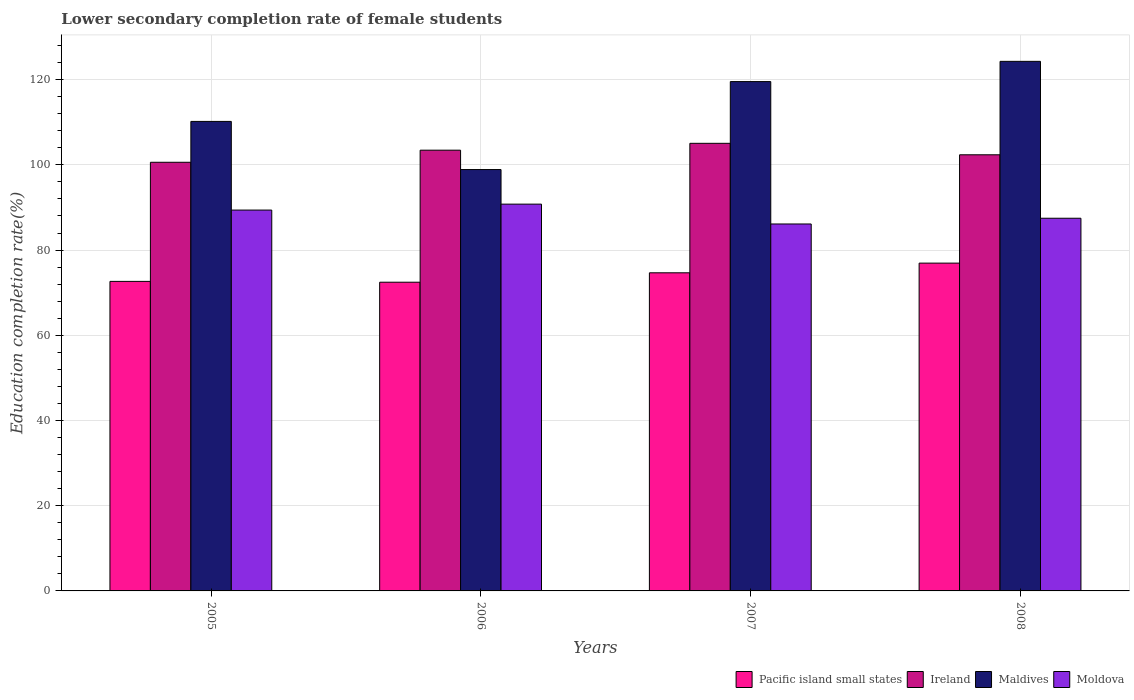How many different coloured bars are there?
Your response must be concise. 4. How many groups of bars are there?
Make the answer very short. 4. Are the number of bars on each tick of the X-axis equal?
Give a very brief answer. Yes. What is the lower secondary completion rate of female students in Moldova in 2006?
Your answer should be compact. 90.78. Across all years, what is the maximum lower secondary completion rate of female students in Ireland?
Your response must be concise. 105.05. Across all years, what is the minimum lower secondary completion rate of female students in Maldives?
Your answer should be compact. 98.89. In which year was the lower secondary completion rate of female students in Maldives maximum?
Your answer should be compact. 2008. In which year was the lower secondary completion rate of female students in Moldova minimum?
Offer a terse response. 2007. What is the total lower secondary completion rate of female students in Moldova in the graph?
Ensure brevity in your answer.  353.75. What is the difference between the lower secondary completion rate of female students in Ireland in 2005 and that in 2007?
Provide a succinct answer. -4.45. What is the difference between the lower secondary completion rate of female students in Ireland in 2007 and the lower secondary completion rate of female students in Moldova in 2005?
Provide a short and direct response. 15.67. What is the average lower secondary completion rate of female students in Maldives per year?
Your answer should be very brief. 113.23. In the year 2008, what is the difference between the lower secondary completion rate of female students in Moldova and lower secondary completion rate of female students in Pacific island small states?
Offer a very short reply. 10.53. What is the ratio of the lower secondary completion rate of female students in Pacific island small states in 2005 to that in 2008?
Provide a short and direct response. 0.94. Is the difference between the lower secondary completion rate of female students in Moldova in 2005 and 2008 greater than the difference between the lower secondary completion rate of female students in Pacific island small states in 2005 and 2008?
Provide a short and direct response. Yes. What is the difference between the highest and the second highest lower secondary completion rate of female students in Pacific island small states?
Ensure brevity in your answer.  2.27. What is the difference between the highest and the lowest lower secondary completion rate of female students in Ireland?
Make the answer very short. 4.45. In how many years, is the lower secondary completion rate of female students in Moldova greater than the average lower secondary completion rate of female students in Moldova taken over all years?
Provide a short and direct response. 2. What does the 4th bar from the left in 2006 represents?
Provide a short and direct response. Moldova. What does the 4th bar from the right in 2006 represents?
Provide a succinct answer. Pacific island small states. Is it the case that in every year, the sum of the lower secondary completion rate of female students in Maldives and lower secondary completion rate of female students in Pacific island small states is greater than the lower secondary completion rate of female students in Ireland?
Your answer should be compact. Yes. How many bars are there?
Your response must be concise. 16. Are all the bars in the graph horizontal?
Give a very brief answer. No. Where does the legend appear in the graph?
Offer a terse response. Bottom right. How many legend labels are there?
Keep it short and to the point. 4. What is the title of the graph?
Your answer should be very brief. Lower secondary completion rate of female students. Does "Spain" appear as one of the legend labels in the graph?
Provide a short and direct response. No. What is the label or title of the Y-axis?
Your answer should be very brief. Education completion rate(%). What is the Education completion rate(%) in Pacific island small states in 2005?
Your response must be concise. 72.65. What is the Education completion rate(%) of Ireland in 2005?
Keep it short and to the point. 100.6. What is the Education completion rate(%) of Maldives in 2005?
Your answer should be very brief. 110.19. What is the Education completion rate(%) in Moldova in 2005?
Your answer should be compact. 89.38. What is the Education completion rate(%) of Pacific island small states in 2006?
Offer a very short reply. 72.45. What is the Education completion rate(%) in Ireland in 2006?
Provide a short and direct response. 103.44. What is the Education completion rate(%) in Maldives in 2006?
Your answer should be very brief. 98.89. What is the Education completion rate(%) in Moldova in 2006?
Make the answer very short. 90.78. What is the Education completion rate(%) of Pacific island small states in 2007?
Your response must be concise. 74.66. What is the Education completion rate(%) of Ireland in 2007?
Offer a very short reply. 105.05. What is the Education completion rate(%) in Maldives in 2007?
Offer a very short reply. 119.54. What is the Education completion rate(%) in Moldova in 2007?
Give a very brief answer. 86.12. What is the Education completion rate(%) in Pacific island small states in 2008?
Make the answer very short. 76.94. What is the Education completion rate(%) of Ireland in 2008?
Offer a terse response. 102.36. What is the Education completion rate(%) of Maldives in 2008?
Your answer should be compact. 124.29. What is the Education completion rate(%) of Moldova in 2008?
Your response must be concise. 87.47. Across all years, what is the maximum Education completion rate(%) of Pacific island small states?
Provide a short and direct response. 76.94. Across all years, what is the maximum Education completion rate(%) in Ireland?
Ensure brevity in your answer.  105.05. Across all years, what is the maximum Education completion rate(%) of Maldives?
Your response must be concise. 124.29. Across all years, what is the maximum Education completion rate(%) of Moldova?
Offer a terse response. 90.78. Across all years, what is the minimum Education completion rate(%) of Pacific island small states?
Make the answer very short. 72.45. Across all years, what is the minimum Education completion rate(%) of Ireland?
Your response must be concise. 100.6. Across all years, what is the minimum Education completion rate(%) of Maldives?
Keep it short and to the point. 98.89. Across all years, what is the minimum Education completion rate(%) in Moldova?
Keep it short and to the point. 86.12. What is the total Education completion rate(%) of Pacific island small states in the graph?
Ensure brevity in your answer.  296.7. What is the total Education completion rate(%) in Ireland in the graph?
Your answer should be compact. 411.46. What is the total Education completion rate(%) in Maldives in the graph?
Ensure brevity in your answer.  452.91. What is the total Education completion rate(%) of Moldova in the graph?
Provide a short and direct response. 353.75. What is the difference between the Education completion rate(%) in Pacific island small states in 2005 and that in 2006?
Provide a short and direct response. 0.19. What is the difference between the Education completion rate(%) of Ireland in 2005 and that in 2006?
Your answer should be very brief. -2.84. What is the difference between the Education completion rate(%) of Maldives in 2005 and that in 2006?
Provide a short and direct response. 11.3. What is the difference between the Education completion rate(%) of Moldova in 2005 and that in 2006?
Make the answer very short. -1.4. What is the difference between the Education completion rate(%) in Pacific island small states in 2005 and that in 2007?
Ensure brevity in your answer.  -2.02. What is the difference between the Education completion rate(%) of Ireland in 2005 and that in 2007?
Your response must be concise. -4.45. What is the difference between the Education completion rate(%) of Maldives in 2005 and that in 2007?
Make the answer very short. -9.35. What is the difference between the Education completion rate(%) in Moldova in 2005 and that in 2007?
Your answer should be very brief. 3.26. What is the difference between the Education completion rate(%) of Pacific island small states in 2005 and that in 2008?
Provide a short and direct response. -4.29. What is the difference between the Education completion rate(%) of Ireland in 2005 and that in 2008?
Make the answer very short. -1.76. What is the difference between the Education completion rate(%) in Maldives in 2005 and that in 2008?
Your answer should be compact. -14.1. What is the difference between the Education completion rate(%) of Moldova in 2005 and that in 2008?
Give a very brief answer. 1.92. What is the difference between the Education completion rate(%) of Pacific island small states in 2006 and that in 2007?
Provide a succinct answer. -2.21. What is the difference between the Education completion rate(%) in Ireland in 2006 and that in 2007?
Make the answer very short. -1.61. What is the difference between the Education completion rate(%) of Maldives in 2006 and that in 2007?
Your answer should be compact. -20.65. What is the difference between the Education completion rate(%) of Moldova in 2006 and that in 2007?
Offer a very short reply. 4.66. What is the difference between the Education completion rate(%) of Pacific island small states in 2006 and that in 2008?
Your answer should be compact. -4.48. What is the difference between the Education completion rate(%) of Ireland in 2006 and that in 2008?
Your answer should be very brief. 1.08. What is the difference between the Education completion rate(%) of Maldives in 2006 and that in 2008?
Ensure brevity in your answer.  -25.4. What is the difference between the Education completion rate(%) of Moldova in 2006 and that in 2008?
Provide a short and direct response. 3.31. What is the difference between the Education completion rate(%) of Pacific island small states in 2007 and that in 2008?
Provide a succinct answer. -2.27. What is the difference between the Education completion rate(%) in Ireland in 2007 and that in 2008?
Ensure brevity in your answer.  2.69. What is the difference between the Education completion rate(%) in Maldives in 2007 and that in 2008?
Offer a very short reply. -4.75. What is the difference between the Education completion rate(%) in Moldova in 2007 and that in 2008?
Ensure brevity in your answer.  -1.34. What is the difference between the Education completion rate(%) of Pacific island small states in 2005 and the Education completion rate(%) of Ireland in 2006?
Provide a succinct answer. -30.79. What is the difference between the Education completion rate(%) of Pacific island small states in 2005 and the Education completion rate(%) of Maldives in 2006?
Your answer should be compact. -26.25. What is the difference between the Education completion rate(%) in Pacific island small states in 2005 and the Education completion rate(%) in Moldova in 2006?
Provide a succinct answer. -18.13. What is the difference between the Education completion rate(%) in Ireland in 2005 and the Education completion rate(%) in Maldives in 2006?
Ensure brevity in your answer.  1.71. What is the difference between the Education completion rate(%) of Ireland in 2005 and the Education completion rate(%) of Moldova in 2006?
Offer a terse response. 9.82. What is the difference between the Education completion rate(%) of Maldives in 2005 and the Education completion rate(%) of Moldova in 2006?
Make the answer very short. 19.41. What is the difference between the Education completion rate(%) of Pacific island small states in 2005 and the Education completion rate(%) of Ireland in 2007?
Give a very brief answer. -32.4. What is the difference between the Education completion rate(%) of Pacific island small states in 2005 and the Education completion rate(%) of Maldives in 2007?
Ensure brevity in your answer.  -46.89. What is the difference between the Education completion rate(%) of Pacific island small states in 2005 and the Education completion rate(%) of Moldova in 2007?
Provide a succinct answer. -13.47. What is the difference between the Education completion rate(%) in Ireland in 2005 and the Education completion rate(%) in Maldives in 2007?
Your answer should be very brief. -18.93. What is the difference between the Education completion rate(%) in Ireland in 2005 and the Education completion rate(%) in Moldova in 2007?
Your response must be concise. 14.48. What is the difference between the Education completion rate(%) in Maldives in 2005 and the Education completion rate(%) in Moldova in 2007?
Provide a succinct answer. 24.07. What is the difference between the Education completion rate(%) in Pacific island small states in 2005 and the Education completion rate(%) in Ireland in 2008?
Give a very brief answer. -29.71. What is the difference between the Education completion rate(%) of Pacific island small states in 2005 and the Education completion rate(%) of Maldives in 2008?
Offer a very short reply. -51.64. What is the difference between the Education completion rate(%) in Pacific island small states in 2005 and the Education completion rate(%) in Moldova in 2008?
Make the answer very short. -14.82. What is the difference between the Education completion rate(%) in Ireland in 2005 and the Education completion rate(%) in Maldives in 2008?
Make the answer very short. -23.69. What is the difference between the Education completion rate(%) of Ireland in 2005 and the Education completion rate(%) of Moldova in 2008?
Offer a terse response. 13.14. What is the difference between the Education completion rate(%) of Maldives in 2005 and the Education completion rate(%) of Moldova in 2008?
Your answer should be compact. 22.73. What is the difference between the Education completion rate(%) in Pacific island small states in 2006 and the Education completion rate(%) in Ireland in 2007?
Your response must be concise. -32.6. What is the difference between the Education completion rate(%) in Pacific island small states in 2006 and the Education completion rate(%) in Maldives in 2007?
Your response must be concise. -47.09. What is the difference between the Education completion rate(%) in Pacific island small states in 2006 and the Education completion rate(%) in Moldova in 2007?
Give a very brief answer. -13.67. What is the difference between the Education completion rate(%) of Ireland in 2006 and the Education completion rate(%) of Maldives in 2007?
Keep it short and to the point. -16.1. What is the difference between the Education completion rate(%) of Ireland in 2006 and the Education completion rate(%) of Moldova in 2007?
Ensure brevity in your answer.  17.32. What is the difference between the Education completion rate(%) in Maldives in 2006 and the Education completion rate(%) in Moldova in 2007?
Your answer should be compact. 12.77. What is the difference between the Education completion rate(%) in Pacific island small states in 2006 and the Education completion rate(%) in Ireland in 2008?
Keep it short and to the point. -29.91. What is the difference between the Education completion rate(%) in Pacific island small states in 2006 and the Education completion rate(%) in Maldives in 2008?
Give a very brief answer. -51.84. What is the difference between the Education completion rate(%) of Pacific island small states in 2006 and the Education completion rate(%) of Moldova in 2008?
Give a very brief answer. -15.01. What is the difference between the Education completion rate(%) of Ireland in 2006 and the Education completion rate(%) of Maldives in 2008?
Your answer should be very brief. -20.85. What is the difference between the Education completion rate(%) in Ireland in 2006 and the Education completion rate(%) in Moldova in 2008?
Keep it short and to the point. 15.98. What is the difference between the Education completion rate(%) of Maldives in 2006 and the Education completion rate(%) of Moldova in 2008?
Keep it short and to the point. 11.43. What is the difference between the Education completion rate(%) in Pacific island small states in 2007 and the Education completion rate(%) in Ireland in 2008?
Offer a terse response. -27.7. What is the difference between the Education completion rate(%) in Pacific island small states in 2007 and the Education completion rate(%) in Maldives in 2008?
Make the answer very short. -49.63. What is the difference between the Education completion rate(%) in Pacific island small states in 2007 and the Education completion rate(%) in Moldova in 2008?
Give a very brief answer. -12.8. What is the difference between the Education completion rate(%) of Ireland in 2007 and the Education completion rate(%) of Maldives in 2008?
Offer a terse response. -19.24. What is the difference between the Education completion rate(%) of Ireland in 2007 and the Education completion rate(%) of Moldova in 2008?
Keep it short and to the point. 17.59. What is the difference between the Education completion rate(%) in Maldives in 2007 and the Education completion rate(%) in Moldova in 2008?
Your answer should be compact. 32.07. What is the average Education completion rate(%) in Pacific island small states per year?
Your response must be concise. 74.17. What is the average Education completion rate(%) of Ireland per year?
Provide a short and direct response. 102.86. What is the average Education completion rate(%) in Maldives per year?
Provide a succinct answer. 113.23. What is the average Education completion rate(%) in Moldova per year?
Your answer should be very brief. 88.44. In the year 2005, what is the difference between the Education completion rate(%) of Pacific island small states and Education completion rate(%) of Ireland?
Ensure brevity in your answer.  -27.96. In the year 2005, what is the difference between the Education completion rate(%) in Pacific island small states and Education completion rate(%) in Maldives?
Provide a short and direct response. -37.55. In the year 2005, what is the difference between the Education completion rate(%) of Pacific island small states and Education completion rate(%) of Moldova?
Your response must be concise. -16.74. In the year 2005, what is the difference between the Education completion rate(%) in Ireland and Education completion rate(%) in Maldives?
Your answer should be compact. -9.59. In the year 2005, what is the difference between the Education completion rate(%) in Ireland and Education completion rate(%) in Moldova?
Provide a succinct answer. 11.22. In the year 2005, what is the difference between the Education completion rate(%) of Maldives and Education completion rate(%) of Moldova?
Give a very brief answer. 20.81. In the year 2006, what is the difference between the Education completion rate(%) of Pacific island small states and Education completion rate(%) of Ireland?
Offer a terse response. -30.99. In the year 2006, what is the difference between the Education completion rate(%) of Pacific island small states and Education completion rate(%) of Maldives?
Provide a short and direct response. -26.44. In the year 2006, what is the difference between the Education completion rate(%) in Pacific island small states and Education completion rate(%) in Moldova?
Keep it short and to the point. -18.33. In the year 2006, what is the difference between the Education completion rate(%) of Ireland and Education completion rate(%) of Maldives?
Ensure brevity in your answer.  4.55. In the year 2006, what is the difference between the Education completion rate(%) in Ireland and Education completion rate(%) in Moldova?
Your response must be concise. 12.66. In the year 2006, what is the difference between the Education completion rate(%) in Maldives and Education completion rate(%) in Moldova?
Provide a short and direct response. 8.11. In the year 2007, what is the difference between the Education completion rate(%) in Pacific island small states and Education completion rate(%) in Ireland?
Your answer should be very brief. -30.39. In the year 2007, what is the difference between the Education completion rate(%) in Pacific island small states and Education completion rate(%) in Maldives?
Provide a succinct answer. -44.88. In the year 2007, what is the difference between the Education completion rate(%) in Pacific island small states and Education completion rate(%) in Moldova?
Your answer should be very brief. -11.46. In the year 2007, what is the difference between the Education completion rate(%) of Ireland and Education completion rate(%) of Maldives?
Provide a short and direct response. -14.49. In the year 2007, what is the difference between the Education completion rate(%) in Ireland and Education completion rate(%) in Moldova?
Your answer should be very brief. 18.93. In the year 2007, what is the difference between the Education completion rate(%) of Maldives and Education completion rate(%) of Moldova?
Provide a short and direct response. 33.42. In the year 2008, what is the difference between the Education completion rate(%) in Pacific island small states and Education completion rate(%) in Ireland?
Your answer should be very brief. -25.42. In the year 2008, what is the difference between the Education completion rate(%) in Pacific island small states and Education completion rate(%) in Maldives?
Make the answer very short. -47.35. In the year 2008, what is the difference between the Education completion rate(%) in Pacific island small states and Education completion rate(%) in Moldova?
Give a very brief answer. -10.53. In the year 2008, what is the difference between the Education completion rate(%) of Ireland and Education completion rate(%) of Maldives?
Offer a terse response. -21.93. In the year 2008, what is the difference between the Education completion rate(%) of Ireland and Education completion rate(%) of Moldova?
Provide a succinct answer. 14.89. In the year 2008, what is the difference between the Education completion rate(%) of Maldives and Education completion rate(%) of Moldova?
Offer a very short reply. 36.82. What is the ratio of the Education completion rate(%) in Pacific island small states in 2005 to that in 2006?
Offer a terse response. 1. What is the ratio of the Education completion rate(%) in Ireland in 2005 to that in 2006?
Your response must be concise. 0.97. What is the ratio of the Education completion rate(%) in Maldives in 2005 to that in 2006?
Provide a succinct answer. 1.11. What is the ratio of the Education completion rate(%) of Moldova in 2005 to that in 2006?
Offer a very short reply. 0.98. What is the ratio of the Education completion rate(%) of Pacific island small states in 2005 to that in 2007?
Give a very brief answer. 0.97. What is the ratio of the Education completion rate(%) in Ireland in 2005 to that in 2007?
Make the answer very short. 0.96. What is the ratio of the Education completion rate(%) of Maldives in 2005 to that in 2007?
Your answer should be very brief. 0.92. What is the ratio of the Education completion rate(%) in Moldova in 2005 to that in 2007?
Your answer should be compact. 1.04. What is the ratio of the Education completion rate(%) in Pacific island small states in 2005 to that in 2008?
Keep it short and to the point. 0.94. What is the ratio of the Education completion rate(%) in Ireland in 2005 to that in 2008?
Offer a terse response. 0.98. What is the ratio of the Education completion rate(%) in Maldives in 2005 to that in 2008?
Keep it short and to the point. 0.89. What is the ratio of the Education completion rate(%) of Moldova in 2005 to that in 2008?
Provide a short and direct response. 1.02. What is the ratio of the Education completion rate(%) of Pacific island small states in 2006 to that in 2007?
Your response must be concise. 0.97. What is the ratio of the Education completion rate(%) of Ireland in 2006 to that in 2007?
Provide a short and direct response. 0.98. What is the ratio of the Education completion rate(%) of Maldives in 2006 to that in 2007?
Provide a short and direct response. 0.83. What is the ratio of the Education completion rate(%) in Moldova in 2006 to that in 2007?
Your answer should be compact. 1.05. What is the ratio of the Education completion rate(%) in Pacific island small states in 2006 to that in 2008?
Provide a succinct answer. 0.94. What is the ratio of the Education completion rate(%) in Ireland in 2006 to that in 2008?
Your answer should be compact. 1.01. What is the ratio of the Education completion rate(%) of Maldives in 2006 to that in 2008?
Offer a very short reply. 0.8. What is the ratio of the Education completion rate(%) in Moldova in 2006 to that in 2008?
Provide a short and direct response. 1.04. What is the ratio of the Education completion rate(%) of Pacific island small states in 2007 to that in 2008?
Your answer should be compact. 0.97. What is the ratio of the Education completion rate(%) of Ireland in 2007 to that in 2008?
Provide a short and direct response. 1.03. What is the ratio of the Education completion rate(%) in Maldives in 2007 to that in 2008?
Ensure brevity in your answer.  0.96. What is the ratio of the Education completion rate(%) in Moldova in 2007 to that in 2008?
Offer a very short reply. 0.98. What is the difference between the highest and the second highest Education completion rate(%) of Pacific island small states?
Make the answer very short. 2.27. What is the difference between the highest and the second highest Education completion rate(%) of Ireland?
Make the answer very short. 1.61. What is the difference between the highest and the second highest Education completion rate(%) in Maldives?
Your answer should be compact. 4.75. What is the difference between the highest and the second highest Education completion rate(%) in Moldova?
Provide a short and direct response. 1.4. What is the difference between the highest and the lowest Education completion rate(%) in Pacific island small states?
Your response must be concise. 4.48. What is the difference between the highest and the lowest Education completion rate(%) of Ireland?
Offer a terse response. 4.45. What is the difference between the highest and the lowest Education completion rate(%) in Maldives?
Your answer should be very brief. 25.4. What is the difference between the highest and the lowest Education completion rate(%) of Moldova?
Offer a very short reply. 4.66. 